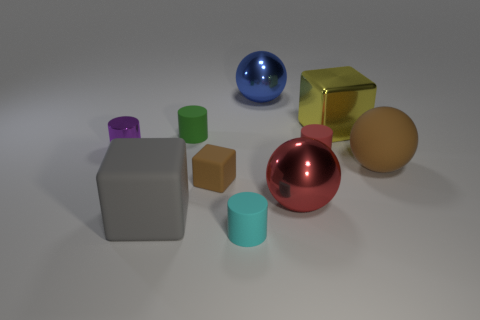Subtract all blocks. How many objects are left? 7 Subtract 0 yellow spheres. How many objects are left? 10 Subtract all green metallic cylinders. Subtract all green objects. How many objects are left? 9 Add 3 red objects. How many red objects are left? 5 Add 7 red shiny balls. How many red shiny balls exist? 8 